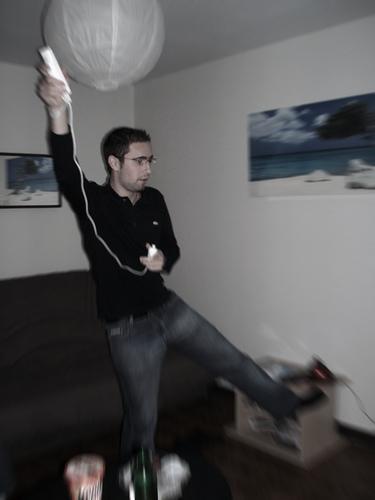How many pictures are behind the man?
Give a very brief answer. 1. 